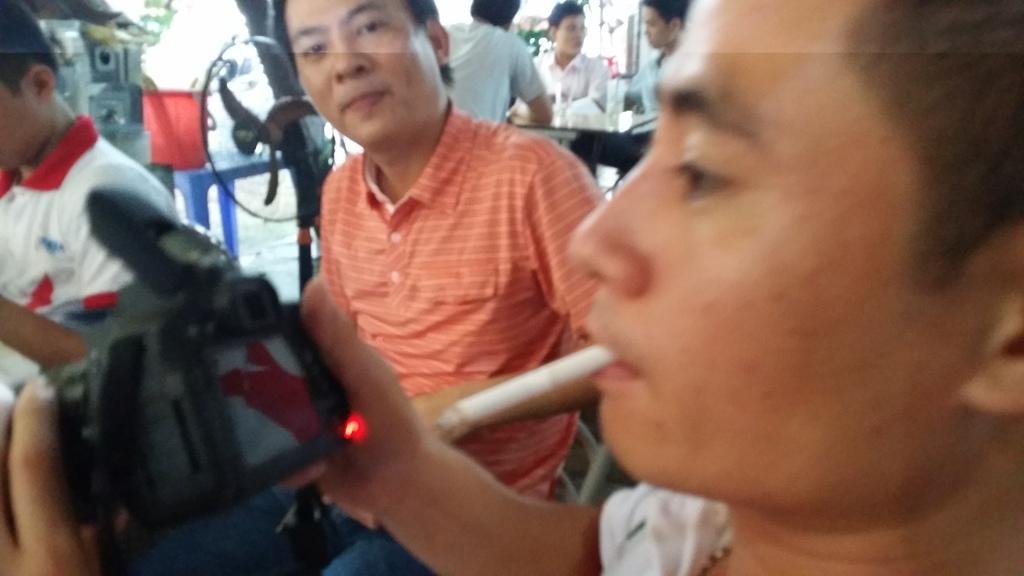Can you describe this image briefly? In this image we can see this man is having cigarette in his mouth and holding a camera in his hands. In the background we can see few people and table fan. 